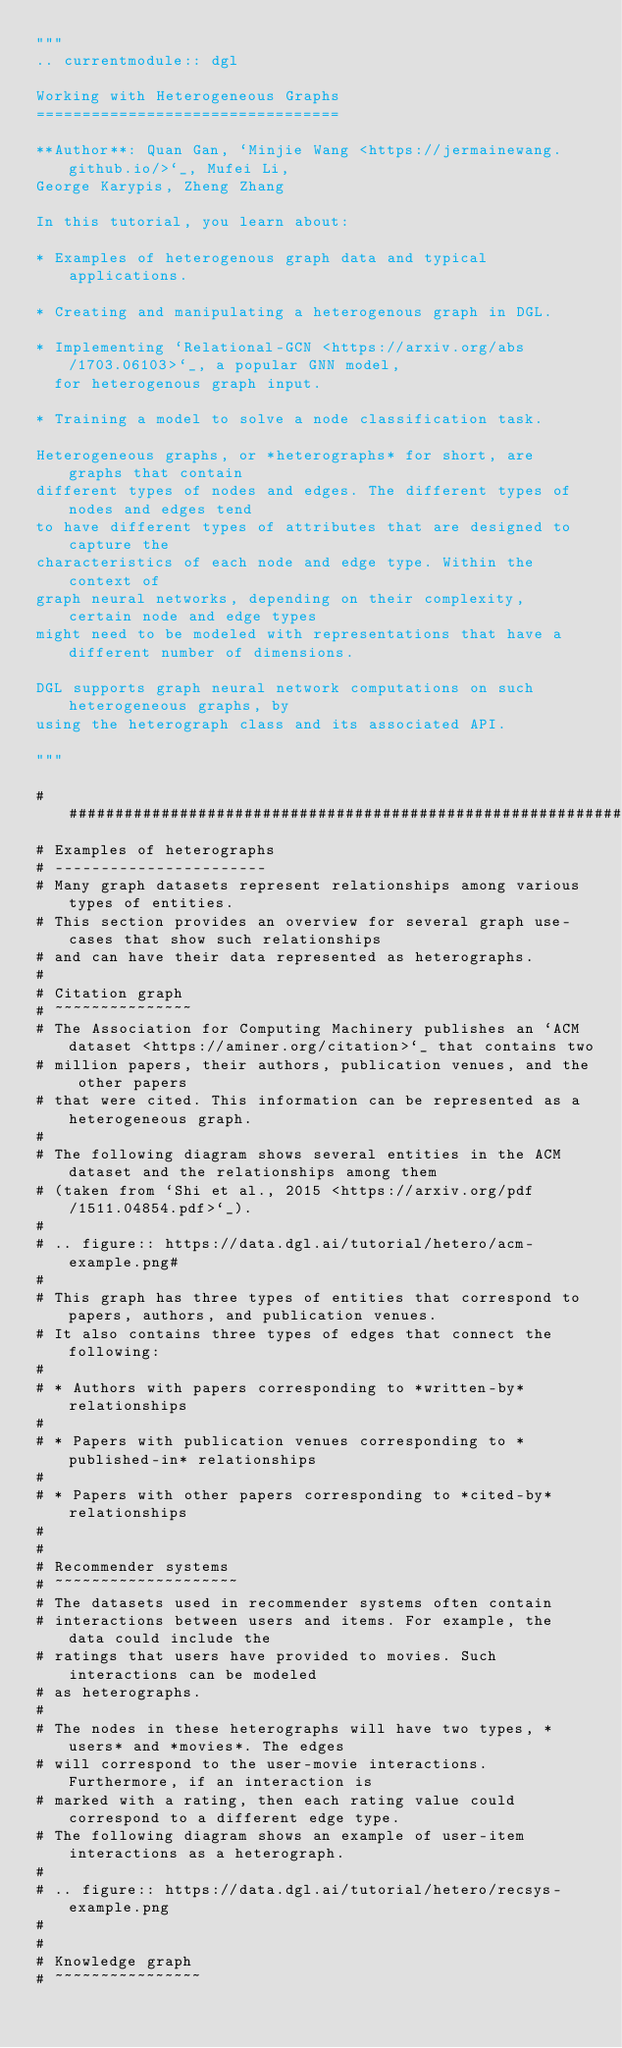<code> <loc_0><loc_0><loc_500><loc_500><_Python_>"""
.. currentmodule:: dgl

Working with Heterogeneous Graphs
=================================

**Author**: Quan Gan, `Minjie Wang <https://jermainewang.github.io/>`_, Mufei Li,
George Karypis, Zheng Zhang

In this tutorial, you learn about:

* Examples of heterogenous graph data and typical applications.

* Creating and manipulating a heterogenous graph in DGL.

* Implementing `Relational-GCN <https://arxiv.org/abs/1703.06103>`_, a popular GNN model,
  for heterogenous graph input.

* Training a model to solve a node classification task.

Heterogeneous graphs, or *heterographs* for short, are graphs that contain
different types of nodes and edges. The different types of nodes and edges tend
to have different types of attributes that are designed to capture the
characteristics of each node and edge type. Within the context of
graph neural networks, depending on their complexity, certain node and edge types
might need to be modeled with representations that have a different number of dimensions.

DGL supports graph neural network computations on such heterogeneous graphs, by
using the heterograph class and its associated API.

"""

###############################################################################
# Examples of heterographs
# -----------------------
# Many graph datasets represent relationships among various types of entities.
# This section provides an overview for several graph use-cases that show such relationships 
# and can have their data represented as heterographs.
#
# Citation graph 
# ~~~~~~~~~~~~~~~
# The Association for Computing Machinery publishes an `ACM dataset <https://aminer.org/citation>`_ that contains two
# million papers, their authors, publication venues, and the other papers
# that were cited. This information can be represented as a heterogeneous graph.
#
# The following diagram shows several entities in the ACM dataset and the relationships among them 
# (taken from `Shi et al., 2015 <https://arxiv.org/pdf/1511.04854.pdf>`_).
#
# .. figure:: https://data.dgl.ai/tutorial/hetero/acm-example.png# 
# 
# This graph has three types of entities that correspond to papers, authors, and publication venues.
# It also contains three types of edges that connect the following:
#
# * Authors with papers corresponding to *written-by* relationships
#
# * Papers with publication venues corresponding to *published-in* relationships
#
# * Papers with other papers corresponding to *cited-by* relationships
#
#
# Recommender systems 
# ~~~~~~~~~~~~~~~~~~~~ 
# The datasets used in recommender systems often contain
# interactions between users and items. For example, the data could include the
# ratings that users have provided to movies. Such interactions can be modeled
# as heterographs.
#
# The nodes in these heterographs will have two types, *users* and *movies*. The edges
# will correspond to the user-movie interactions. Furthermore, if an interaction is
# marked with a rating, then each rating value could correspond to a different edge type.
# The following diagram shows an example of user-item interactions as a heterograph.
#
# .. figure:: https://data.dgl.ai/tutorial/hetero/recsys-example.png
#
#
# Knowledge graph 
# ~~~~~~~~~~~~~~~~</code> 